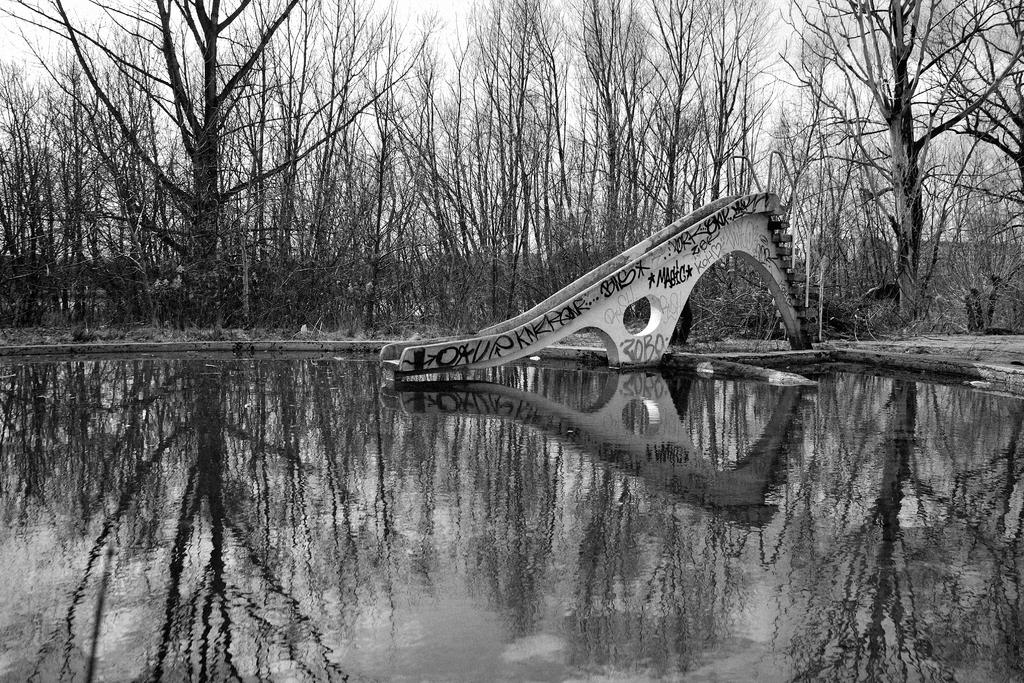What is the color scheme of the image? The image is black and white. What can be seen in the water in the image? There is a slide in the water. What type of vegetation is visible in the background of the image? There are tall trees in the background. What is visible at the bottom of the image? There is water visible at the bottom of the image. How many crows are sitting on the slide in the image? There are no crows present in the image. What type of trip is being taken by the people in the image? There are no people visible in the image, so it is not possible to determine if they are on a trip. 